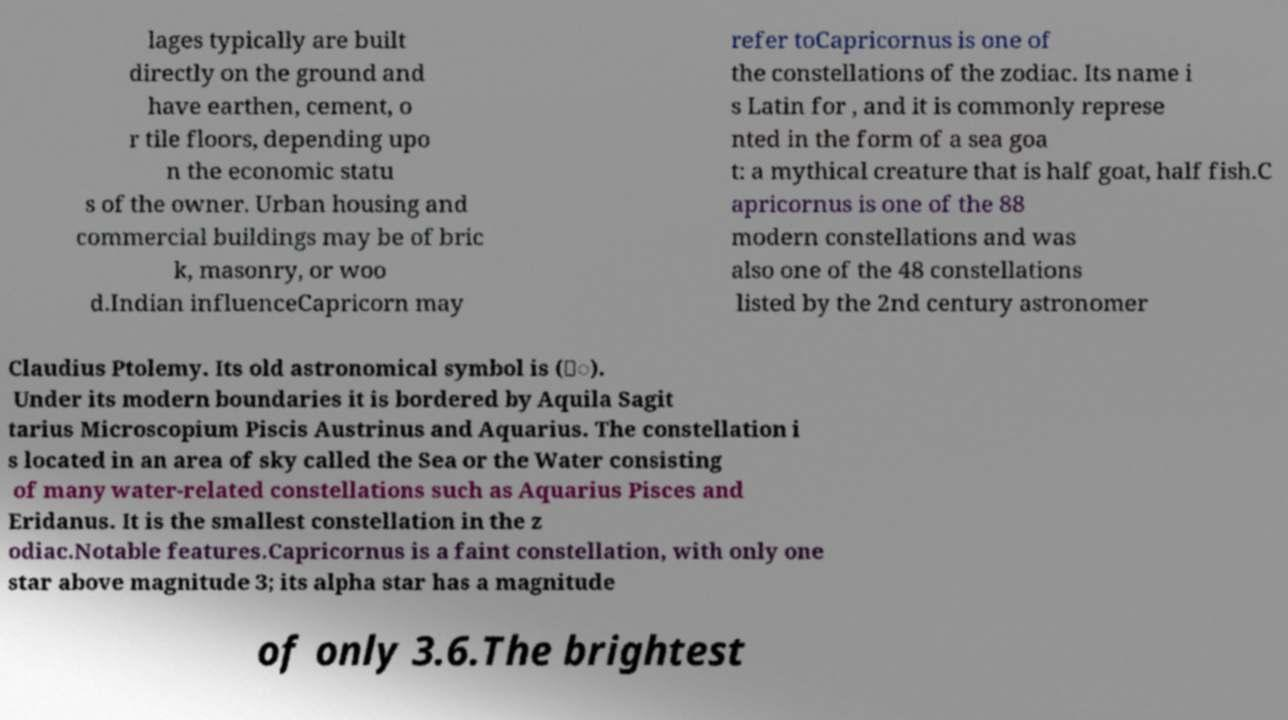Please read and relay the text visible in this image. What does it say? lages typically are built directly on the ground and have earthen, cement, o r tile floors, depending upo n the economic statu s of the owner. Urban housing and commercial buildings may be of bric k, masonry, or woo d.Indian influenceCapricorn may refer toCapricornus is one of the constellations of the zodiac. Its name i s Latin for , and it is commonly represe nted in the form of a sea goa t: a mythical creature that is half goat, half fish.C apricornus is one of the 88 modern constellations and was also one of the 48 constellations listed by the 2nd century astronomer Claudius Ptolemy. Its old astronomical symbol is (♑︎). Under its modern boundaries it is bordered by Aquila Sagit tarius Microscopium Piscis Austrinus and Aquarius. The constellation i s located in an area of sky called the Sea or the Water consisting of many water-related constellations such as Aquarius Pisces and Eridanus. It is the smallest constellation in the z odiac.Notable features.Capricornus is a faint constellation, with only one star above magnitude 3; its alpha star has a magnitude of only 3.6.The brightest 